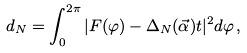<formula> <loc_0><loc_0><loc_500><loc_500>d _ { N } = \int _ { 0 } ^ { 2 \pi } | F ( \varphi ) - \Delta _ { N } ( \vec { \alpha } ) t | ^ { 2 } d \varphi \, ,</formula> 